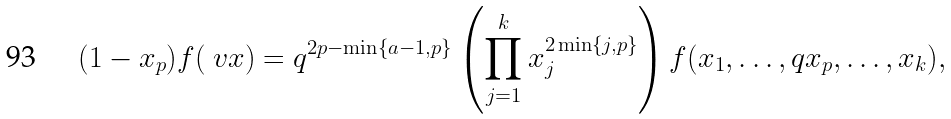Convert formula to latex. <formula><loc_0><loc_0><loc_500><loc_500>( 1 - x _ { p } ) f ( \ v x ) = q ^ { 2 p - \min \{ a - 1 , p \} } \left ( \prod _ { j = 1 } ^ { k } x _ { j } ^ { 2 \min \{ j , p \} } \right ) f ( x _ { 1 } , \dots , q x _ { p } , \dots , x _ { k } ) ,</formula> 